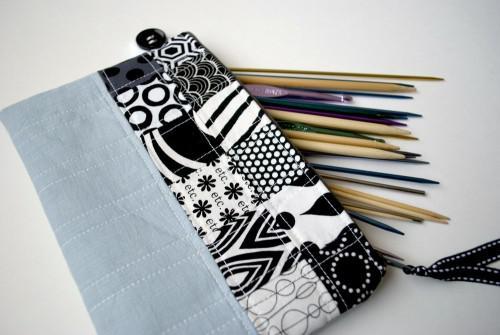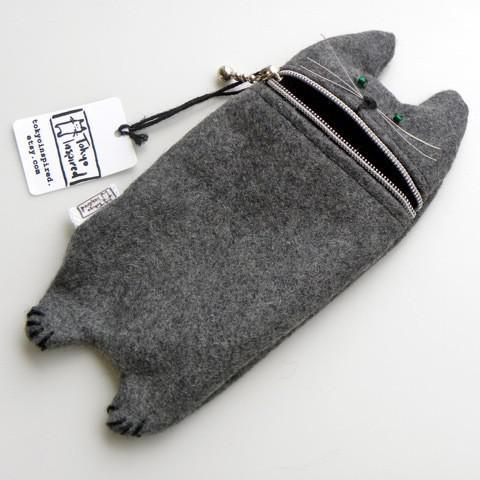The first image is the image on the left, the second image is the image on the right. For the images shown, is this caption "One image shows a black-and-white pencil case made of patterned fabric, and the other shows a case with a phrase across the front." true? Answer yes or no. No. The first image is the image on the left, the second image is the image on the right. Examine the images to the left and right. Is the description "There are exactly two pencil bags, and there are pencils and/or pens sticking out of the left one." accurate? Answer yes or no. Yes. 